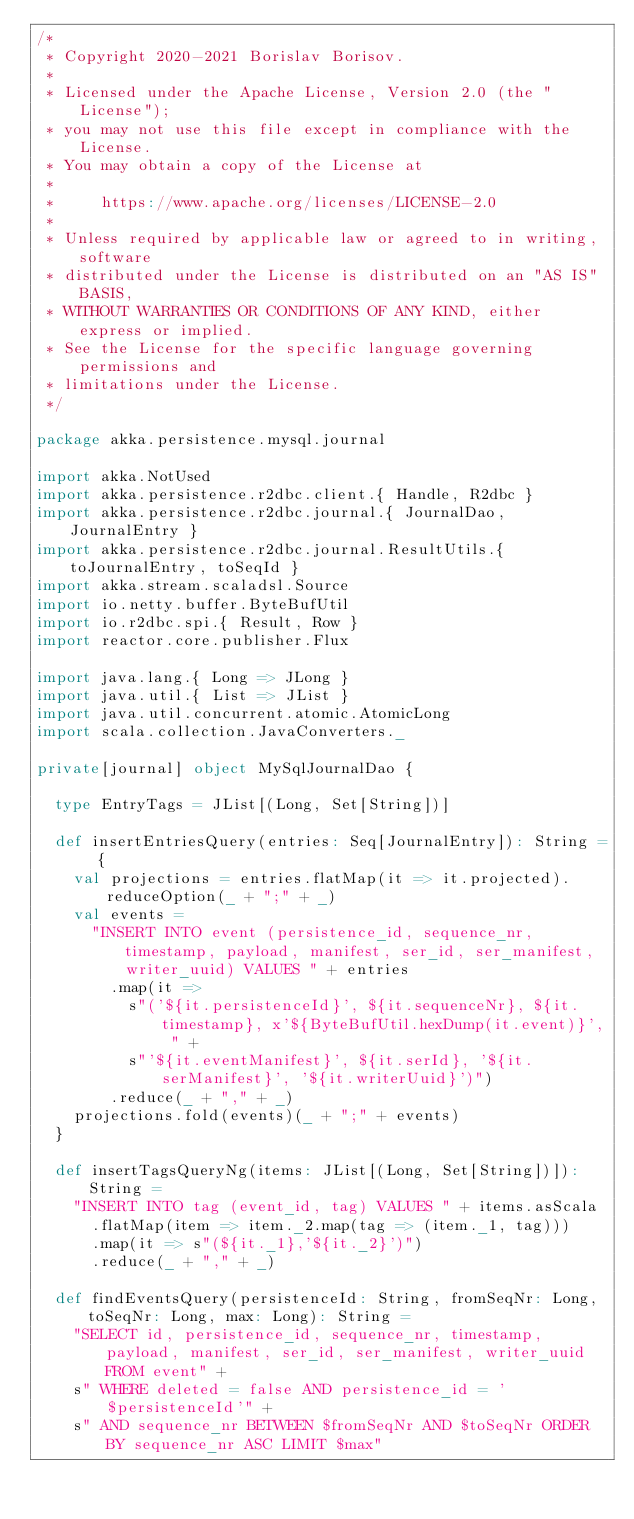<code> <loc_0><loc_0><loc_500><loc_500><_Scala_>/*
 * Copyright 2020-2021 Borislav Borisov.
 *
 * Licensed under the Apache License, Version 2.0 (the "License");
 * you may not use this file except in compliance with the License.
 * You may obtain a copy of the License at
 *
 *     https://www.apache.org/licenses/LICENSE-2.0
 *
 * Unless required by applicable law or agreed to in writing, software
 * distributed under the License is distributed on an "AS IS" BASIS,
 * WITHOUT WARRANTIES OR CONDITIONS OF ANY KIND, either express or implied.
 * See the License for the specific language governing permissions and
 * limitations under the License.
 */

package akka.persistence.mysql.journal

import akka.NotUsed
import akka.persistence.r2dbc.client.{ Handle, R2dbc }
import akka.persistence.r2dbc.journal.{ JournalDao, JournalEntry }
import akka.persistence.r2dbc.journal.ResultUtils.{ toJournalEntry, toSeqId }
import akka.stream.scaladsl.Source
import io.netty.buffer.ByteBufUtil
import io.r2dbc.spi.{ Result, Row }
import reactor.core.publisher.Flux

import java.lang.{ Long => JLong }
import java.util.{ List => JList }
import java.util.concurrent.atomic.AtomicLong
import scala.collection.JavaConverters._

private[journal] object MySqlJournalDao {

  type EntryTags = JList[(Long, Set[String])]

  def insertEntriesQuery(entries: Seq[JournalEntry]): String = {
    val projections = entries.flatMap(it => it.projected).reduceOption(_ + ";" + _)
    val events =
      "INSERT INTO event (persistence_id, sequence_nr, timestamp, payload, manifest, ser_id, ser_manifest, writer_uuid) VALUES " + entries
        .map(it =>
          s"('${it.persistenceId}', ${it.sequenceNr}, ${it.timestamp}, x'${ByteBufUtil.hexDump(it.event)}', " +
          s"'${it.eventManifest}', ${it.serId}, '${it.serManifest}', '${it.writerUuid}')")
        .reduce(_ + "," + _)
    projections.fold(events)(_ + ";" + events)
  }

  def insertTagsQueryNg(items: JList[(Long, Set[String])]): String =
    "INSERT INTO tag (event_id, tag) VALUES " + items.asScala
      .flatMap(item => item._2.map(tag => (item._1, tag)))
      .map(it => s"(${it._1},'${it._2}')")
      .reduce(_ + "," + _)

  def findEventsQuery(persistenceId: String, fromSeqNr: Long, toSeqNr: Long, max: Long): String =
    "SELECT id, persistence_id, sequence_nr, timestamp, payload, manifest, ser_id, ser_manifest, writer_uuid FROM event" +
    s" WHERE deleted = false AND persistence_id = '$persistenceId'" +
    s" AND sequence_nr BETWEEN $fromSeqNr AND $toSeqNr ORDER BY sequence_nr ASC LIMIT $max"
</code> 